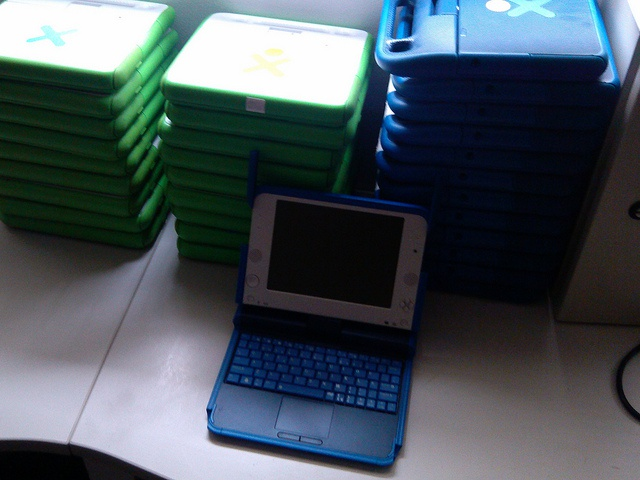Describe the objects in this image and their specific colors. I can see laptop in gray, black, white, and lightblue tones, laptop in gray, black, navy, and blue tones, laptop in gray, black, navy, and blue tones, laptop in gray, white, black, darkgreen, and lightgreen tones, and laptop in gray, black, teal, navy, and green tones in this image. 